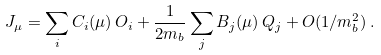Convert formula to latex. <formula><loc_0><loc_0><loc_500><loc_500>J _ { \mu } = \sum _ { i } C _ { i } ( \mu ) \, O _ { i } + \frac { 1 } { 2 m _ { b } } \sum _ { j } B _ { j } ( \mu ) \, Q _ { j } + O ( 1 / m _ { b } ^ { 2 } ) \, .</formula> 